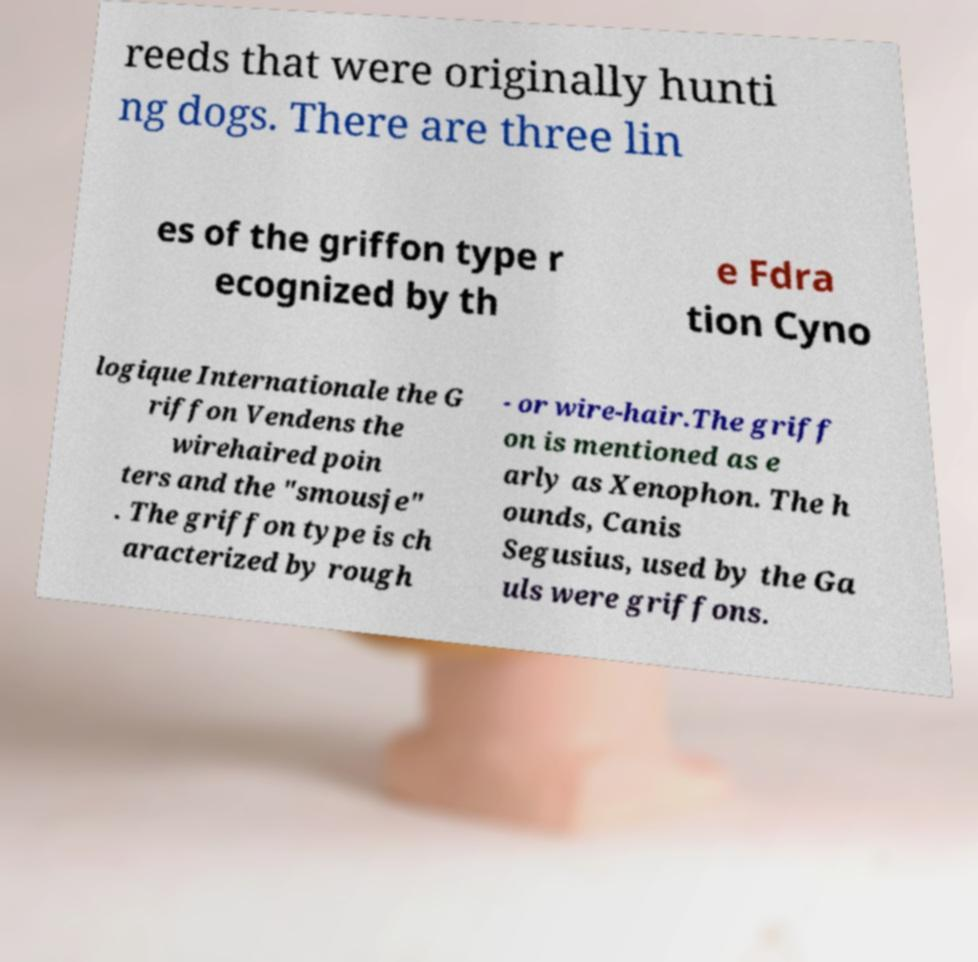Could you assist in decoding the text presented in this image and type it out clearly? reeds that were originally hunti ng dogs. There are three lin es of the griffon type r ecognized by th e Fdra tion Cyno logique Internationale the G riffon Vendens the wirehaired poin ters and the "smousje" . The griffon type is ch aracterized by rough - or wire-hair.The griff on is mentioned as e arly as Xenophon. The h ounds, Canis Segusius, used by the Ga uls were griffons. 